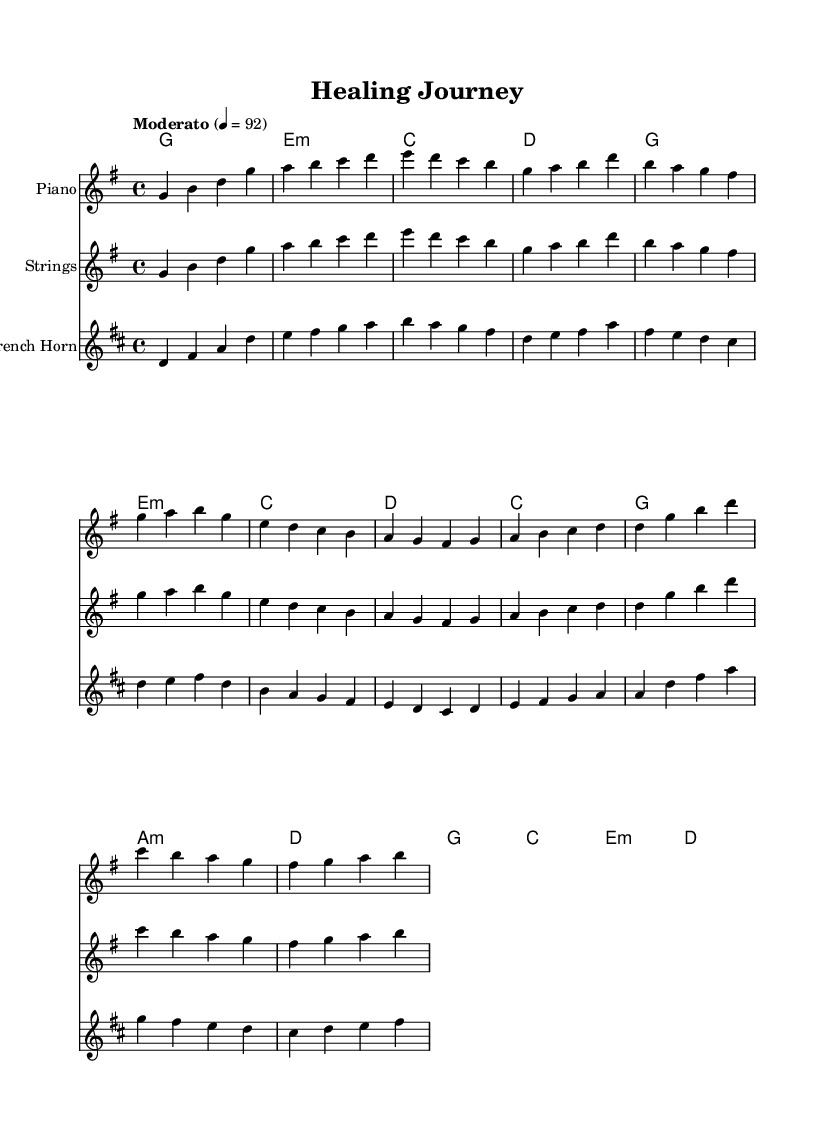What is the key signature of this music? The key signature is G major, which has one sharp (F#).
Answer: G major What is the time signature of this music? The time signature is 4/4, indicating four beats in each measure.
Answer: 4/4 What is the tempo marking of the piece? The tempo marking indicates a Moderato tempo, which typically means a moderate pace.
Answer: Moderato How many sections are there in the music? There are four distinct sections: Intro, Verse, Pre-Chorus, and Chorus.
Answer: Four What type of ensemble is this music intended for? The music is written for a piano, strings, and a French horn, indicating a chamber ensemble arrangement.
Answer: Chamber ensemble In which section does the melody first rise to its highest pitch? In the Chorus section, the melody reaches the highest pitch when it goes from d to g.
Answer: Chorus What is the first chord played in the piece? The first chord is G major, as indicated in the harmonies section.
Answer: G major 